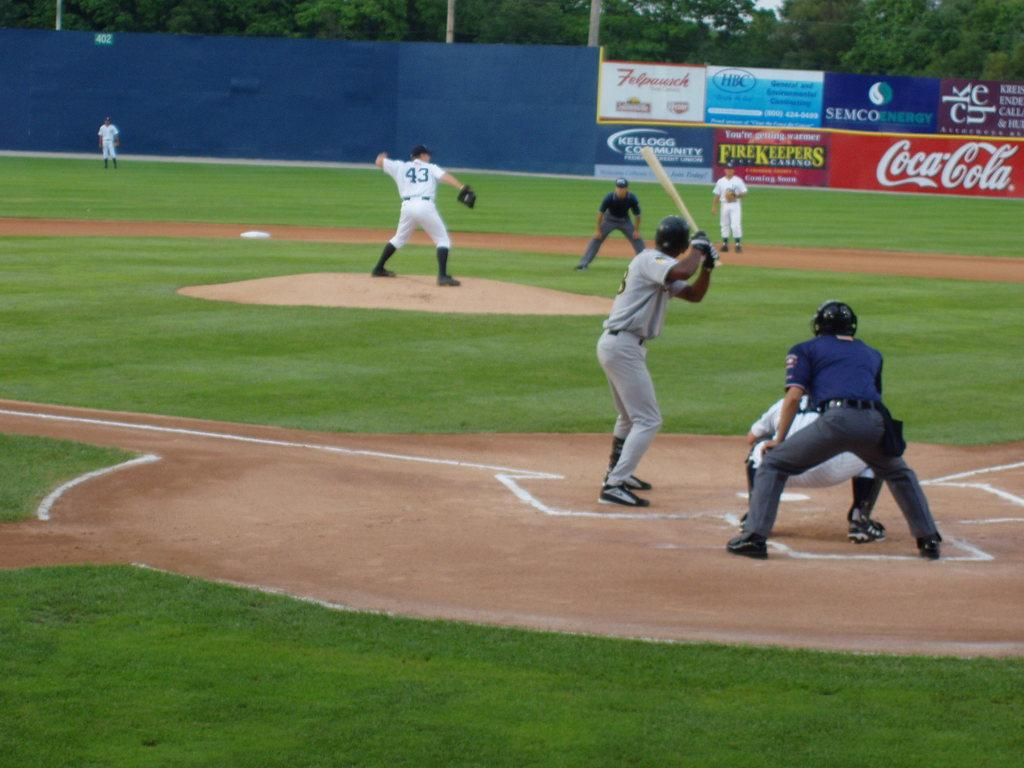<image>
Describe the image concisely. Various signs, including Kellogg Community, FireKeepers and Coca-Cola signs are seen on the fence as baseball pitcher number 43 prepares to pitch. 